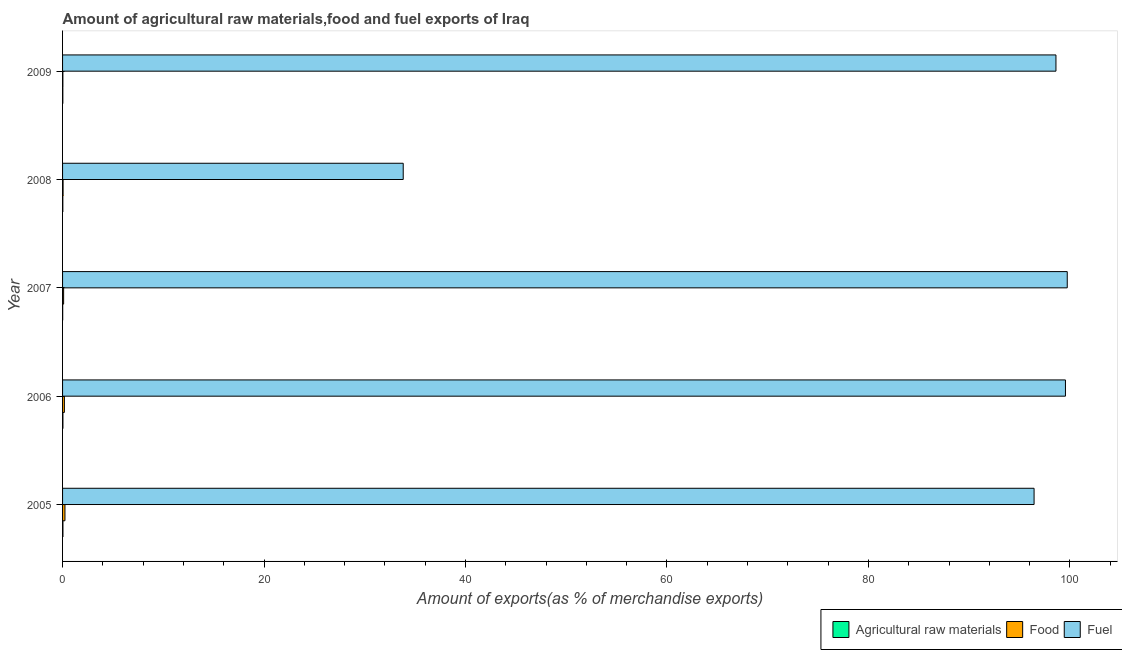Are the number of bars per tick equal to the number of legend labels?
Give a very brief answer. Yes. Are the number of bars on each tick of the Y-axis equal?
Keep it short and to the point. Yes. What is the label of the 5th group of bars from the top?
Provide a succinct answer. 2005. In how many cases, is the number of bars for a given year not equal to the number of legend labels?
Provide a succinct answer. 0. What is the percentage of raw materials exports in 2008?
Your response must be concise. 0.03. Across all years, what is the maximum percentage of food exports?
Your answer should be compact. 0.24. Across all years, what is the minimum percentage of food exports?
Give a very brief answer. 0.03. In which year was the percentage of fuel exports minimum?
Provide a succinct answer. 2008. What is the total percentage of food exports in the graph?
Offer a terse response. 0.6. What is the difference between the percentage of fuel exports in 2006 and that in 2007?
Offer a very short reply. -0.18. What is the difference between the percentage of food exports in 2007 and the percentage of raw materials exports in 2009?
Offer a terse response. 0.08. What is the average percentage of food exports per year?
Provide a succinct answer. 0.12. In the year 2006, what is the difference between the percentage of food exports and percentage of raw materials exports?
Provide a short and direct response. 0.15. In how many years, is the percentage of food exports greater than 4 %?
Offer a very short reply. 0. What is the ratio of the percentage of fuel exports in 2005 to that in 2009?
Your answer should be compact. 0.98. Is the difference between the percentage of fuel exports in 2007 and 2009 greater than the difference between the percentage of raw materials exports in 2007 and 2009?
Provide a short and direct response. Yes. What is the difference between the highest and the second highest percentage of fuel exports?
Provide a short and direct response. 0.18. What is the difference between the highest and the lowest percentage of raw materials exports?
Offer a terse response. 0.03. In how many years, is the percentage of raw materials exports greater than the average percentage of raw materials exports taken over all years?
Your answer should be very brief. 2. Is the sum of the percentage of fuel exports in 2006 and 2009 greater than the maximum percentage of raw materials exports across all years?
Your answer should be very brief. Yes. What does the 3rd bar from the top in 2006 represents?
Provide a short and direct response. Agricultural raw materials. What does the 2nd bar from the bottom in 2005 represents?
Ensure brevity in your answer.  Food. How many bars are there?
Your answer should be very brief. 15. Are the values on the major ticks of X-axis written in scientific E-notation?
Your response must be concise. No. Does the graph contain grids?
Your answer should be compact. No. Where does the legend appear in the graph?
Your answer should be compact. Bottom right. How many legend labels are there?
Give a very brief answer. 3. What is the title of the graph?
Your answer should be very brief. Amount of agricultural raw materials,food and fuel exports of Iraq. What is the label or title of the X-axis?
Give a very brief answer. Amount of exports(as % of merchandise exports). What is the label or title of the Y-axis?
Your answer should be very brief. Year. What is the Amount of exports(as % of merchandise exports) in Agricultural raw materials in 2005?
Provide a short and direct response. 0.04. What is the Amount of exports(as % of merchandise exports) of Food in 2005?
Provide a succinct answer. 0.24. What is the Amount of exports(as % of merchandise exports) of Fuel in 2005?
Provide a succinct answer. 96.45. What is the Amount of exports(as % of merchandise exports) in Agricultural raw materials in 2006?
Your answer should be compact. 0.03. What is the Amount of exports(as % of merchandise exports) of Food in 2006?
Your answer should be compact. 0.18. What is the Amount of exports(as % of merchandise exports) in Fuel in 2006?
Your answer should be very brief. 99.56. What is the Amount of exports(as % of merchandise exports) of Agricultural raw materials in 2007?
Your response must be concise. 0.01. What is the Amount of exports(as % of merchandise exports) of Food in 2007?
Provide a succinct answer. 0.1. What is the Amount of exports(as % of merchandise exports) of Fuel in 2007?
Your answer should be very brief. 99.74. What is the Amount of exports(as % of merchandise exports) in Agricultural raw materials in 2008?
Ensure brevity in your answer.  0.03. What is the Amount of exports(as % of merchandise exports) of Food in 2008?
Your answer should be compact. 0.05. What is the Amount of exports(as % of merchandise exports) of Fuel in 2008?
Make the answer very short. 33.82. What is the Amount of exports(as % of merchandise exports) in Agricultural raw materials in 2009?
Ensure brevity in your answer.  0.03. What is the Amount of exports(as % of merchandise exports) of Food in 2009?
Provide a succinct answer. 0.03. What is the Amount of exports(as % of merchandise exports) of Fuel in 2009?
Offer a terse response. 98.62. Across all years, what is the maximum Amount of exports(as % of merchandise exports) in Agricultural raw materials?
Keep it short and to the point. 0.04. Across all years, what is the maximum Amount of exports(as % of merchandise exports) in Food?
Keep it short and to the point. 0.24. Across all years, what is the maximum Amount of exports(as % of merchandise exports) in Fuel?
Your response must be concise. 99.74. Across all years, what is the minimum Amount of exports(as % of merchandise exports) in Agricultural raw materials?
Give a very brief answer. 0.01. Across all years, what is the minimum Amount of exports(as % of merchandise exports) in Food?
Your answer should be very brief. 0.03. Across all years, what is the minimum Amount of exports(as % of merchandise exports) in Fuel?
Ensure brevity in your answer.  33.82. What is the total Amount of exports(as % of merchandise exports) in Agricultural raw materials in the graph?
Your answer should be very brief. 0.14. What is the total Amount of exports(as % of merchandise exports) in Food in the graph?
Make the answer very short. 0.6. What is the total Amount of exports(as % of merchandise exports) in Fuel in the graph?
Ensure brevity in your answer.  428.18. What is the difference between the Amount of exports(as % of merchandise exports) in Agricultural raw materials in 2005 and that in 2006?
Make the answer very short. 0. What is the difference between the Amount of exports(as % of merchandise exports) in Food in 2005 and that in 2006?
Make the answer very short. 0.06. What is the difference between the Amount of exports(as % of merchandise exports) of Fuel in 2005 and that in 2006?
Your answer should be very brief. -3.12. What is the difference between the Amount of exports(as % of merchandise exports) in Agricultural raw materials in 2005 and that in 2007?
Provide a short and direct response. 0.03. What is the difference between the Amount of exports(as % of merchandise exports) of Food in 2005 and that in 2007?
Provide a succinct answer. 0.13. What is the difference between the Amount of exports(as % of merchandise exports) of Fuel in 2005 and that in 2007?
Offer a terse response. -3.29. What is the difference between the Amount of exports(as % of merchandise exports) in Agricultural raw materials in 2005 and that in 2008?
Provide a short and direct response. 0.01. What is the difference between the Amount of exports(as % of merchandise exports) of Food in 2005 and that in 2008?
Offer a very short reply. 0.19. What is the difference between the Amount of exports(as % of merchandise exports) of Fuel in 2005 and that in 2008?
Offer a very short reply. 62.63. What is the difference between the Amount of exports(as % of merchandise exports) of Agricultural raw materials in 2005 and that in 2009?
Keep it short and to the point. 0.01. What is the difference between the Amount of exports(as % of merchandise exports) in Food in 2005 and that in 2009?
Ensure brevity in your answer.  0.21. What is the difference between the Amount of exports(as % of merchandise exports) of Fuel in 2005 and that in 2009?
Provide a succinct answer. -2.17. What is the difference between the Amount of exports(as % of merchandise exports) in Agricultural raw materials in 2006 and that in 2007?
Your response must be concise. 0.02. What is the difference between the Amount of exports(as % of merchandise exports) in Food in 2006 and that in 2007?
Your answer should be compact. 0.08. What is the difference between the Amount of exports(as % of merchandise exports) of Fuel in 2006 and that in 2007?
Your answer should be compact. -0.18. What is the difference between the Amount of exports(as % of merchandise exports) of Agricultural raw materials in 2006 and that in 2008?
Ensure brevity in your answer.  0.01. What is the difference between the Amount of exports(as % of merchandise exports) in Food in 2006 and that in 2008?
Keep it short and to the point. 0.13. What is the difference between the Amount of exports(as % of merchandise exports) in Fuel in 2006 and that in 2008?
Keep it short and to the point. 65.74. What is the difference between the Amount of exports(as % of merchandise exports) of Agricultural raw materials in 2006 and that in 2009?
Provide a short and direct response. 0.01. What is the difference between the Amount of exports(as % of merchandise exports) of Food in 2006 and that in 2009?
Your answer should be very brief. 0.15. What is the difference between the Amount of exports(as % of merchandise exports) in Fuel in 2006 and that in 2009?
Provide a succinct answer. 0.94. What is the difference between the Amount of exports(as % of merchandise exports) in Agricultural raw materials in 2007 and that in 2008?
Your response must be concise. -0.01. What is the difference between the Amount of exports(as % of merchandise exports) of Food in 2007 and that in 2008?
Your answer should be compact. 0.05. What is the difference between the Amount of exports(as % of merchandise exports) in Fuel in 2007 and that in 2008?
Keep it short and to the point. 65.92. What is the difference between the Amount of exports(as % of merchandise exports) in Agricultural raw materials in 2007 and that in 2009?
Your answer should be very brief. -0.01. What is the difference between the Amount of exports(as % of merchandise exports) in Food in 2007 and that in 2009?
Make the answer very short. 0.07. What is the difference between the Amount of exports(as % of merchandise exports) in Fuel in 2007 and that in 2009?
Your response must be concise. 1.12. What is the difference between the Amount of exports(as % of merchandise exports) in Agricultural raw materials in 2008 and that in 2009?
Provide a succinct answer. 0. What is the difference between the Amount of exports(as % of merchandise exports) of Food in 2008 and that in 2009?
Keep it short and to the point. 0.02. What is the difference between the Amount of exports(as % of merchandise exports) of Fuel in 2008 and that in 2009?
Your answer should be very brief. -64.8. What is the difference between the Amount of exports(as % of merchandise exports) of Agricultural raw materials in 2005 and the Amount of exports(as % of merchandise exports) of Food in 2006?
Give a very brief answer. -0.14. What is the difference between the Amount of exports(as % of merchandise exports) of Agricultural raw materials in 2005 and the Amount of exports(as % of merchandise exports) of Fuel in 2006?
Ensure brevity in your answer.  -99.52. What is the difference between the Amount of exports(as % of merchandise exports) in Food in 2005 and the Amount of exports(as % of merchandise exports) in Fuel in 2006?
Give a very brief answer. -99.32. What is the difference between the Amount of exports(as % of merchandise exports) in Agricultural raw materials in 2005 and the Amount of exports(as % of merchandise exports) in Food in 2007?
Your answer should be compact. -0.07. What is the difference between the Amount of exports(as % of merchandise exports) in Agricultural raw materials in 2005 and the Amount of exports(as % of merchandise exports) in Fuel in 2007?
Ensure brevity in your answer.  -99.7. What is the difference between the Amount of exports(as % of merchandise exports) of Food in 2005 and the Amount of exports(as % of merchandise exports) of Fuel in 2007?
Provide a succinct answer. -99.5. What is the difference between the Amount of exports(as % of merchandise exports) of Agricultural raw materials in 2005 and the Amount of exports(as % of merchandise exports) of Food in 2008?
Provide a succinct answer. -0.01. What is the difference between the Amount of exports(as % of merchandise exports) of Agricultural raw materials in 2005 and the Amount of exports(as % of merchandise exports) of Fuel in 2008?
Provide a succinct answer. -33.78. What is the difference between the Amount of exports(as % of merchandise exports) in Food in 2005 and the Amount of exports(as % of merchandise exports) in Fuel in 2008?
Make the answer very short. -33.58. What is the difference between the Amount of exports(as % of merchandise exports) in Agricultural raw materials in 2005 and the Amount of exports(as % of merchandise exports) in Food in 2009?
Give a very brief answer. 0.01. What is the difference between the Amount of exports(as % of merchandise exports) of Agricultural raw materials in 2005 and the Amount of exports(as % of merchandise exports) of Fuel in 2009?
Provide a succinct answer. -98.58. What is the difference between the Amount of exports(as % of merchandise exports) in Food in 2005 and the Amount of exports(as % of merchandise exports) in Fuel in 2009?
Your answer should be compact. -98.38. What is the difference between the Amount of exports(as % of merchandise exports) of Agricultural raw materials in 2006 and the Amount of exports(as % of merchandise exports) of Food in 2007?
Give a very brief answer. -0.07. What is the difference between the Amount of exports(as % of merchandise exports) of Agricultural raw materials in 2006 and the Amount of exports(as % of merchandise exports) of Fuel in 2007?
Give a very brief answer. -99.7. What is the difference between the Amount of exports(as % of merchandise exports) in Food in 2006 and the Amount of exports(as % of merchandise exports) in Fuel in 2007?
Make the answer very short. -99.56. What is the difference between the Amount of exports(as % of merchandise exports) of Agricultural raw materials in 2006 and the Amount of exports(as % of merchandise exports) of Food in 2008?
Provide a succinct answer. -0.02. What is the difference between the Amount of exports(as % of merchandise exports) in Agricultural raw materials in 2006 and the Amount of exports(as % of merchandise exports) in Fuel in 2008?
Your response must be concise. -33.78. What is the difference between the Amount of exports(as % of merchandise exports) of Food in 2006 and the Amount of exports(as % of merchandise exports) of Fuel in 2008?
Your response must be concise. -33.64. What is the difference between the Amount of exports(as % of merchandise exports) of Agricultural raw materials in 2006 and the Amount of exports(as % of merchandise exports) of Food in 2009?
Your answer should be compact. 0. What is the difference between the Amount of exports(as % of merchandise exports) in Agricultural raw materials in 2006 and the Amount of exports(as % of merchandise exports) in Fuel in 2009?
Your answer should be compact. -98.58. What is the difference between the Amount of exports(as % of merchandise exports) of Food in 2006 and the Amount of exports(as % of merchandise exports) of Fuel in 2009?
Offer a terse response. -98.44. What is the difference between the Amount of exports(as % of merchandise exports) in Agricultural raw materials in 2007 and the Amount of exports(as % of merchandise exports) in Food in 2008?
Give a very brief answer. -0.04. What is the difference between the Amount of exports(as % of merchandise exports) in Agricultural raw materials in 2007 and the Amount of exports(as % of merchandise exports) in Fuel in 2008?
Make the answer very short. -33.81. What is the difference between the Amount of exports(as % of merchandise exports) in Food in 2007 and the Amount of exports(as % of merchandise exports) in Fuel in 2008?
Your response must be concise. -33.71. What is the difference between the Amount of exports(as % of merchandise exports) in Agricultural raw materials in 2007 and the Amount of exports(as % of merchandise exports) in Food in 2009?
Offer a terse response. -0.02. What is the difference between the Amount of exports(as % of merchandise exports) in Agricultural raw materials in 2007 and the Amount of exports(as % of merchandise exports) in Fuel in 2009?
Provide a succinct answer. -98.61. What is the difference between the Amount of exports(as % of merchandise exports) in Food in 2007 and the Amount of exports(as % of merchandise exports) in Fuel in 2009?
Ensure brevity in your answer.  -98.51. What is the difference between the Amount of exports(as % of merchandise exports) in Agricultural raw materials in 2008 and the Amount of exports(as % of merchandise exports) in Food in 2009?
Offer a very short reply. -0. What is the difference between the Amount of exports(as % of merchandise exports) in Agricultural raw materials in 2008 and the Amount of exports(as % of merchandise exports) in Fuel in 2009?
Give a very brief answer. -98.59. What is the difference between the Amount of exports(as % of merchandise exports) in Food in 2008 and the Amount of exports(as % of merchandise exports) in Fuel in 2009?
Offer a terse response. -98.57. What is the average Amount of exports(as % of merchandise exports) in Agricultural raw materials per year?
Make the answer very short. 0.03. What is the average Amount of exports(as % of merchandise exports) in Food per year?
Provide a short and direct response. 0.12. What is the average Amount of exports(as % of merchandise exports) in Fuel per year?
Give a very brief answer. 85.64. In the year 2005, what is the difference between the Amount of exports(as % of merchandise exports) in Agricultural raw materials and Amount of exports(as % of merchandise exports) in Food?
Offer a terse response. -0.2. In the year 2005, what is the difference between the Amount of exports(as % of merchandise exports) of Agricultural raw materials and Amount of exports(as % of merchandise exports) of Fuel?
Make the answer very short. -96.41. In the year 2005, what is the difference between the Amount of exports(as % of merchandise exports) in Food and Amount of exports(as % of merchandise exports) in Fuel?
Offer a very short reply. -96.21. In the year 2006, what is the difference between the Amount of exports(as % of merchandise exports) in Agricultural raw materials and Amount of exports(as % of merchandise exports) in Food?
Offer a terse response. -0.15. In the year 2006, what is the difference between the Amount of exports(as % of merchandise exports) in Agricultural raw materials and Amount of exports(as % of merchandise exports) in Fuel?
Offer a very short reply. -99.53. In the year 2006, what is the difference between the Amount of exports(as % of merchandise exports) of Food and Amount of exports(as % of merchandise exports) of Fuel?
Give a very brief answer. -99.38. In the year 2007, what is the difference between the Amount of exports(as % of merchandise exports) of Agricultural raw materials and Amount of exports(as % of merchandise exports) of Food?
Give a very brief answer. -0.09. In the year 2007, what is the difference between the Amount of exports(as % of merchandise exports) in Agricultural raw materials and Amount of exports(as % of merchandise exports) in Fuel?
Your answer should be very brief. -99.73. In the year 2007, what is the difference between the Amount of exports(as % of merchandise exports) of Food and Amount of exports(as % of merchandise exports) of Fuel?
Give a very brief answer. -99.64. In the year 2008, what is the difference between the Amount of exports(as % of merchandise exports) of Agricultural raw materials and Amount of exports(as % of merchandise exports) of Food?
Provide a short and direct response. -0.03. In the year 2008, what is the difference between the Amount of exports(as % of merchandise exports) in Agricultural raw materials and Amount of exports(as % of merchandise exports) in Fuel?
Your answer should be compact. -33.79. In the year 2008, what is the difference between the Amount of exports(as % of merchandise exports) in Food and Amount of exports(as % of merchandise exports) in Fuel?
Your answer should be very brief. -33.77. In the year 2009, what is the difference between the Amount of exports(as % of merchandise exports) of Agricultural raw materials and Amount of exports(as % of merchandise exports) of Food?
Offer a terse response. -0. In the year 2009, what is the difference between the Amount of exports(as % of merchandise exports) of Agricultural raw materials and Amount of exports(as % of merchandise exports) of Fuel?
Your answer should be very brief. -98.59. In the year 2009, what is the difference between the Amount of exports(as % of merchandise exports) in Food and Amount of exports(as % of merchandise exports) in Fuel?
Offer a very short reply. -98.59. What is the ratio of the Amount of exports(as % of merchandise exports) of Agricultural raw materials in 2005 to that in 2006?
Keep it short and to the point. 1.07. What is the ratio of the Amount of exports(as % of merchandise exports) of Food in 2005 to that in 2006?
Keep it short and to the point. 1.31. What is the ratio of the Amount of exports(as % of merchandise exports) in Fuel in 2005 to that in 2006?
Provide a succinct answer. 0.97. What is the ratio of the Amount of exports(as % of merchandise exports) in Agricultural raw materials in 2005 to that in 2007?
Provide a short and direct response. 3.25. What is the ratio of the Amount of exports(as % of merchandise exports) in Food in 2005 to that in 2007?
Your answer should be compact. 2.27. What is the ratio of the Amount of exports(as % of merchandise exports) of Agricultural raw materials in 2005 to that in 2008?
Provide a succinct answer. 1.41. What is the ratio of the Amount of exports(as % of merchandise exports) of Food in 2005 to that in 2008?
Keep it short and to the point. 4.6. What is the ratio of the Amount of exports(as % of merchandise exports) in Fuel in 2005 to that in 2008?
Your answer should be very brief. 2.85. What is the ratio of the Amount of exports(as % of merchandise exports) in Agricultural raw materials in 2005 to that in 2009?
Offer a very short reply. 1.44. What is the ratio of the Amount of exports(as % of merchandise exports) in Food in 2005 to that in 2009?
Provide a succinct answer. 7.78. What is the ratio of the Amount of exports(as % of merchandise exports) of Agricultural raw materials in 2006 to that in 2007?
Your answer should be very brief. 3.05. What is the ratio of the Amount of exports(as % of merchandise exports) in Food in 2006 to that in 2007?
Keep it short and to the point. 1.73. What is the ratio of the Amount of exports(as % of merchandise exports) in Fuel in 2006 to that in 2007?
Ensure brevity in your answer.  1. What is the ratio of the Amount of exports(as % of merchandise exports) of Agricultural raw materials in 2006 to that in 2008?
Ensure brevity in your answer.  1.32. What is the ratio of the Amount of exports(as % of merchandise exports) in Food in 2006 to that in 2008?
Your answer should be very brief. 3.51. What is the ratio of the Amount of exports(as % of merchandise exports) in Fuel in 2006 to that in 2008?
Your answer should be compact. 2.94. What is the ratio of the Amount of exports(as % of merchandise exports) in Agricultural raw materials in 2006 to that in 2009?
Provide a succinct answer. 1.35. What is the ratio of the Amount of exports(as % of merchandise exports) of Food in 2006 to that in 2009?
Make the answer very short. 5.93. What is the ratio of the Amount of exports(as % of merchandise exports) in Fuel in 2006 to that in 2009?
Ensure brevity in your answer.  1.01. What is the ratio of the Amount of exports(as % of merchandise exports) of Agricultural raw materials in 2007 to that in 2008?
Your answer should be compact. 0.43. What is the ratio of the Amount of exports(as % of merchandise exports) in Food in 2007 to that in 2008?
Offer a very short reply. 2.03. What is the ratio of the Amount of exports(as % of merchandise exports) of Fuel in 2007 to that in 2008?
Make the answer very short. 2.95. What is the ratio of the Amount of exports(as % of merchandise exports) in Agricultural raw materials in 2007 to that in 2009?
Give a very brief answer. 0.44. What is the ratio of the Amount of exports(as % of merchandise exports) in Food in 2007 to that in 2009?
Make the answer very short. 3.42. What is the ratio of the Amount of exports(as % of merchandise exports) of Fuel in 2007 to that in 2009?
Provide a succinct answer. 1.01. What is the ratio of the Amount of exports(as % of merchandise exports) of Agricultural raw materials in 2008 to that in 2009?
Offer a terse response. 1.02. What is the ratio of the Amount of exports(as % of merchandise exports) in Food in 2008 to that in 2009?
Your answer should be compact. 1.69. What is the ratio of the Amount of exports(as % of merchandise exports) of Fuel in 2008 to that in 2009?
Offer a very short reply. 0.34. What is the difference between the highest and the second highest Amount of exports(as % of merchandise exports) of Agricultural raw materials?
Offer a terse response. 0. What is the difference between the highest and the second highest Amount of exports(as % of merchandise exports) in Food?
Ensure brevity in your answer.  0.06. What is the difference between the highest and the second highest Amount of exports(as % of merchandise exports) of Fuel?
Make the answer very short. 0.18. What is the difference between the highest and the lowest Amount of exports(as % of merchandise exports) of Agricultural raw materials?
Your answer should be compact. 0.03. What is the difference between the highest and the lowest Amount of exports(as % of merchandise exports) of Food?
Ensure brevity in your answer.  0.21. What is the difference between the highest and the lowest Amount of exports(as % of merchandise exports) of Fuel?
Provide a short and direct response. 65.92. 